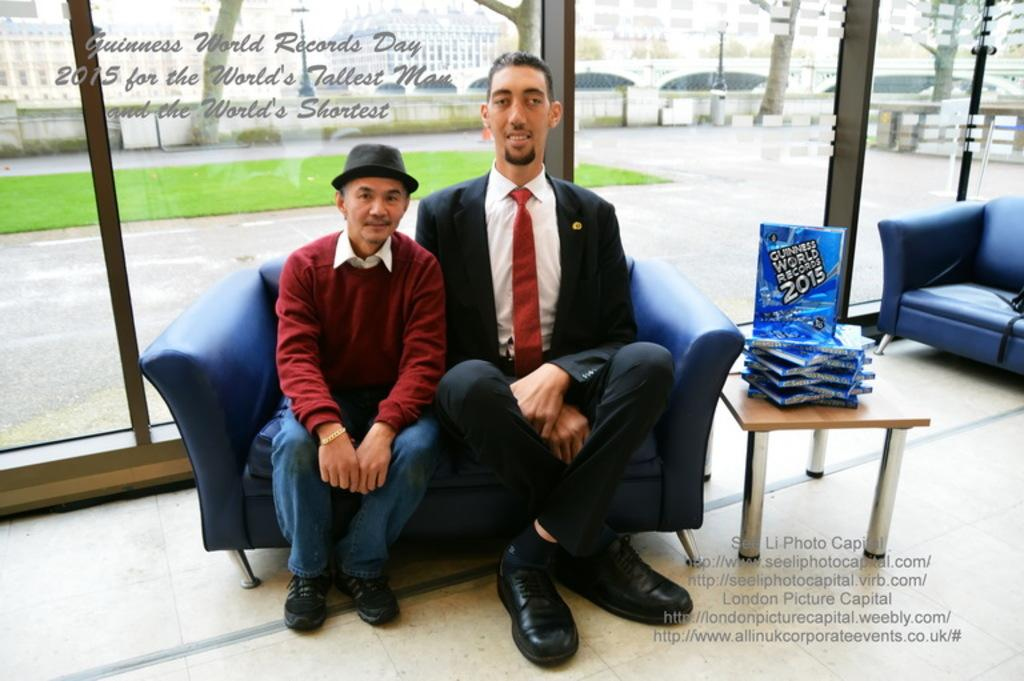How many people are sitting on the sofa in the image? There are two persons sitting on the sofa in the image. What is located near the sofa? There is a table near the sofa. What can be found on the table? There are objects on the table. What type of container is visible in the image? There is a glass visible in the image. What type of flooring is present in the image? Grass is present on the floor. What type of word can be seen written on the glass in the image? There is no word written on the glass in the image. What type of juice is being served in the glass in the image? There is no juice present in the image; only a glass is visible. 